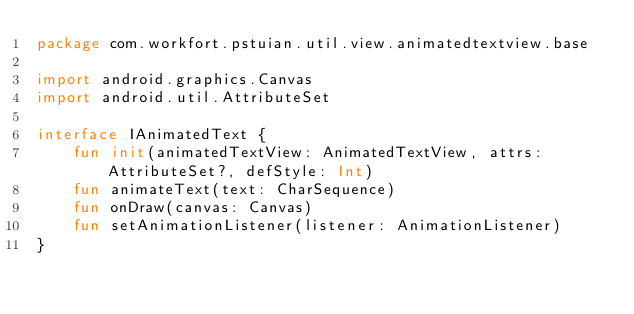<code> <loc_0><loc_0><loc_500><loc_500><_Kotlin_>package com.workfort.pstuian.util.view.animatedtextview.base

import android.graphics.Canvas
import android.util.AttributeSet

interface IAnimatedText {
    fun init(animatedTextView: AnimatedTextView, attrs: AttributeSet?, defStyle: Int)
    fun animateText(text: CharSequence)
    fun onDraw(canvas: Canvas)
    fun setAnimationListener(listener: AnimationListener)
}</code> 